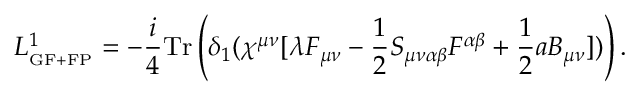<formula> <loc_0><loc_0><loc_500><loc_500>L _ { _ { G F + F P } } ^ { 1 } = - \frac { i } { 4 } T r \left ( \delta _ { 1 } ( \chi ^ { \mu \nu } [ \lambda F _ { \mu \nu } - \frac { 1 } { 2 } S _ { \mu \nu \alpha \beta } F ^ { \alpha \beta } + \frac { 1 } { 2 } a B _ { \mu \nu } ] ) \right ) .</formula> 